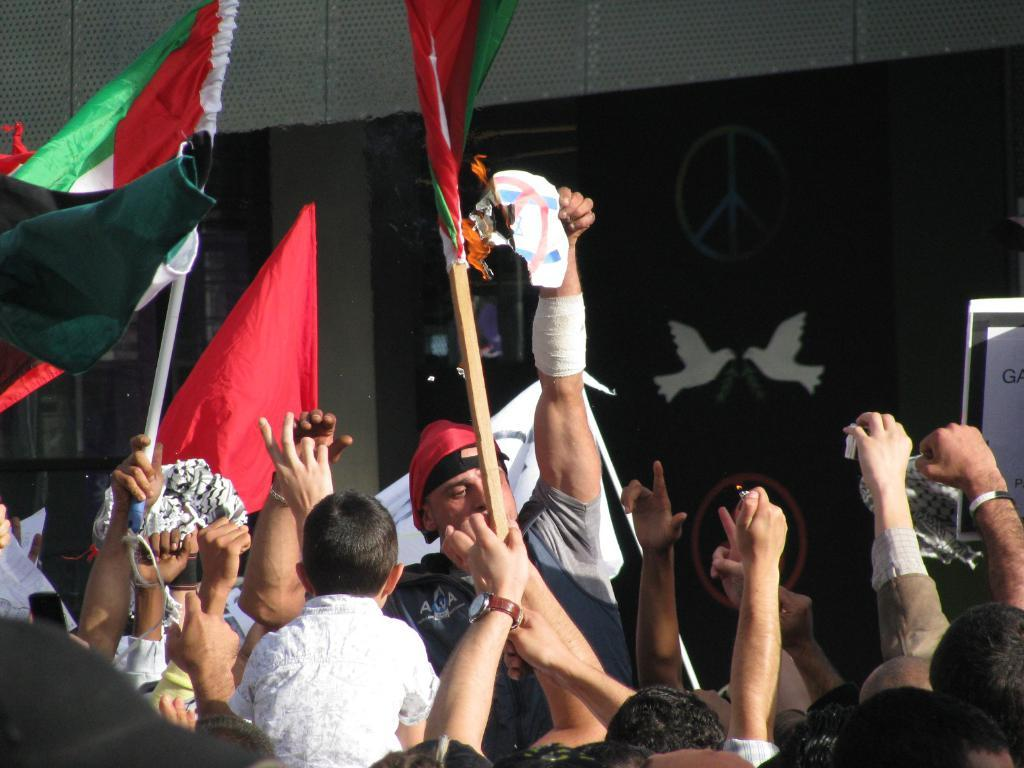What are the persons in the image doing? The persons in the image are standing and holding flags in their hands. What can be seen in the background of the image? There are walls and at least one pillar in the background of the image. What type of toothbrush is being used by the persons in the image? There is no toothbrush present in the image; the persons are holding flags. What is the cause of the cough that can be heard from the persons in the image? There is no cough or sound mentioned in the image; the focus is on the persons holding flags. 